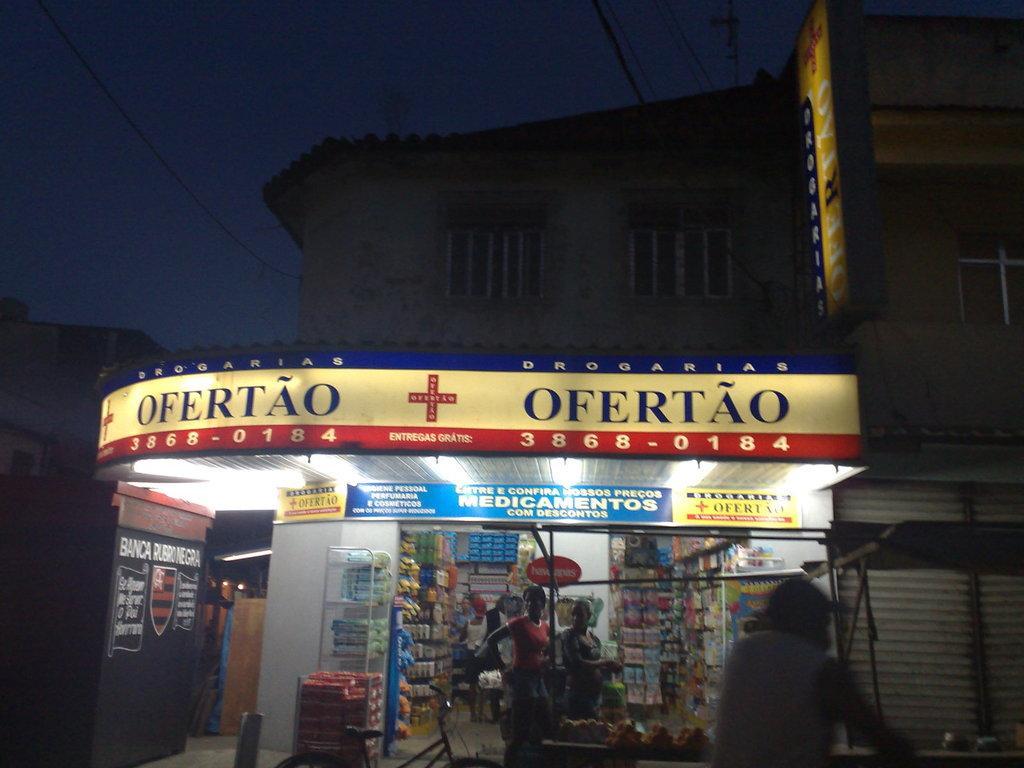In one or two sentences, can you explain what this image depicts? In the picture we can see a medical shop with some persons standing near it and in the shop we can see medicines in the racks and to the ceiling we can see lights and in the background we can see a building with windows and behind it we can see wires and sky. 